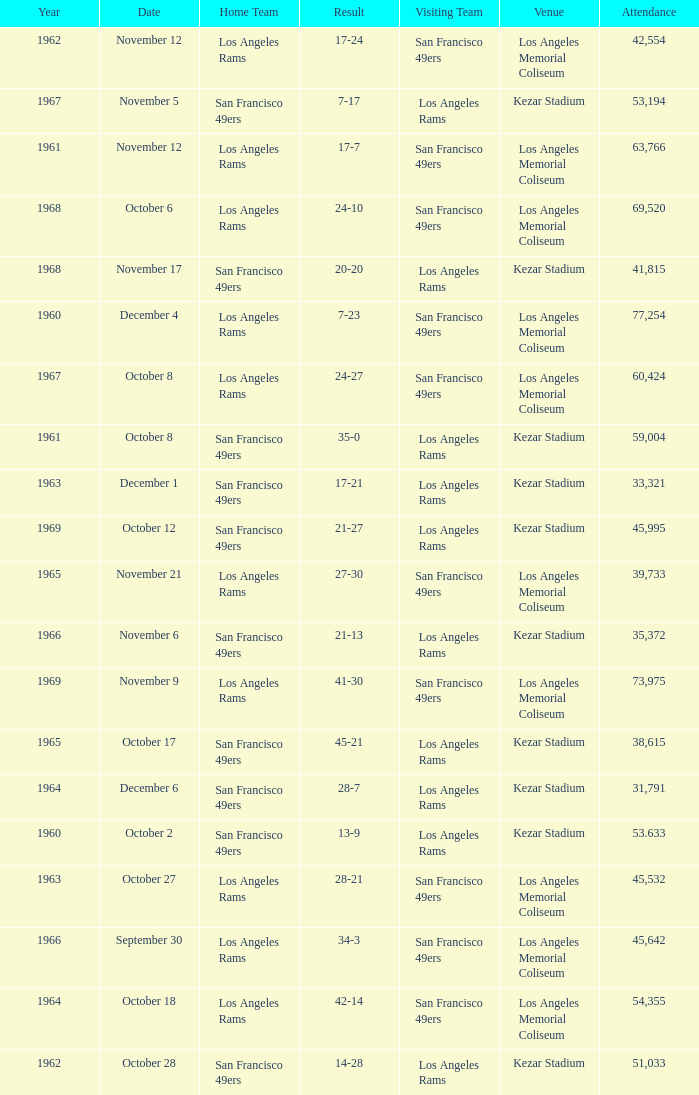When was the earliest year when the attendance was 77,254? 1960.0. 